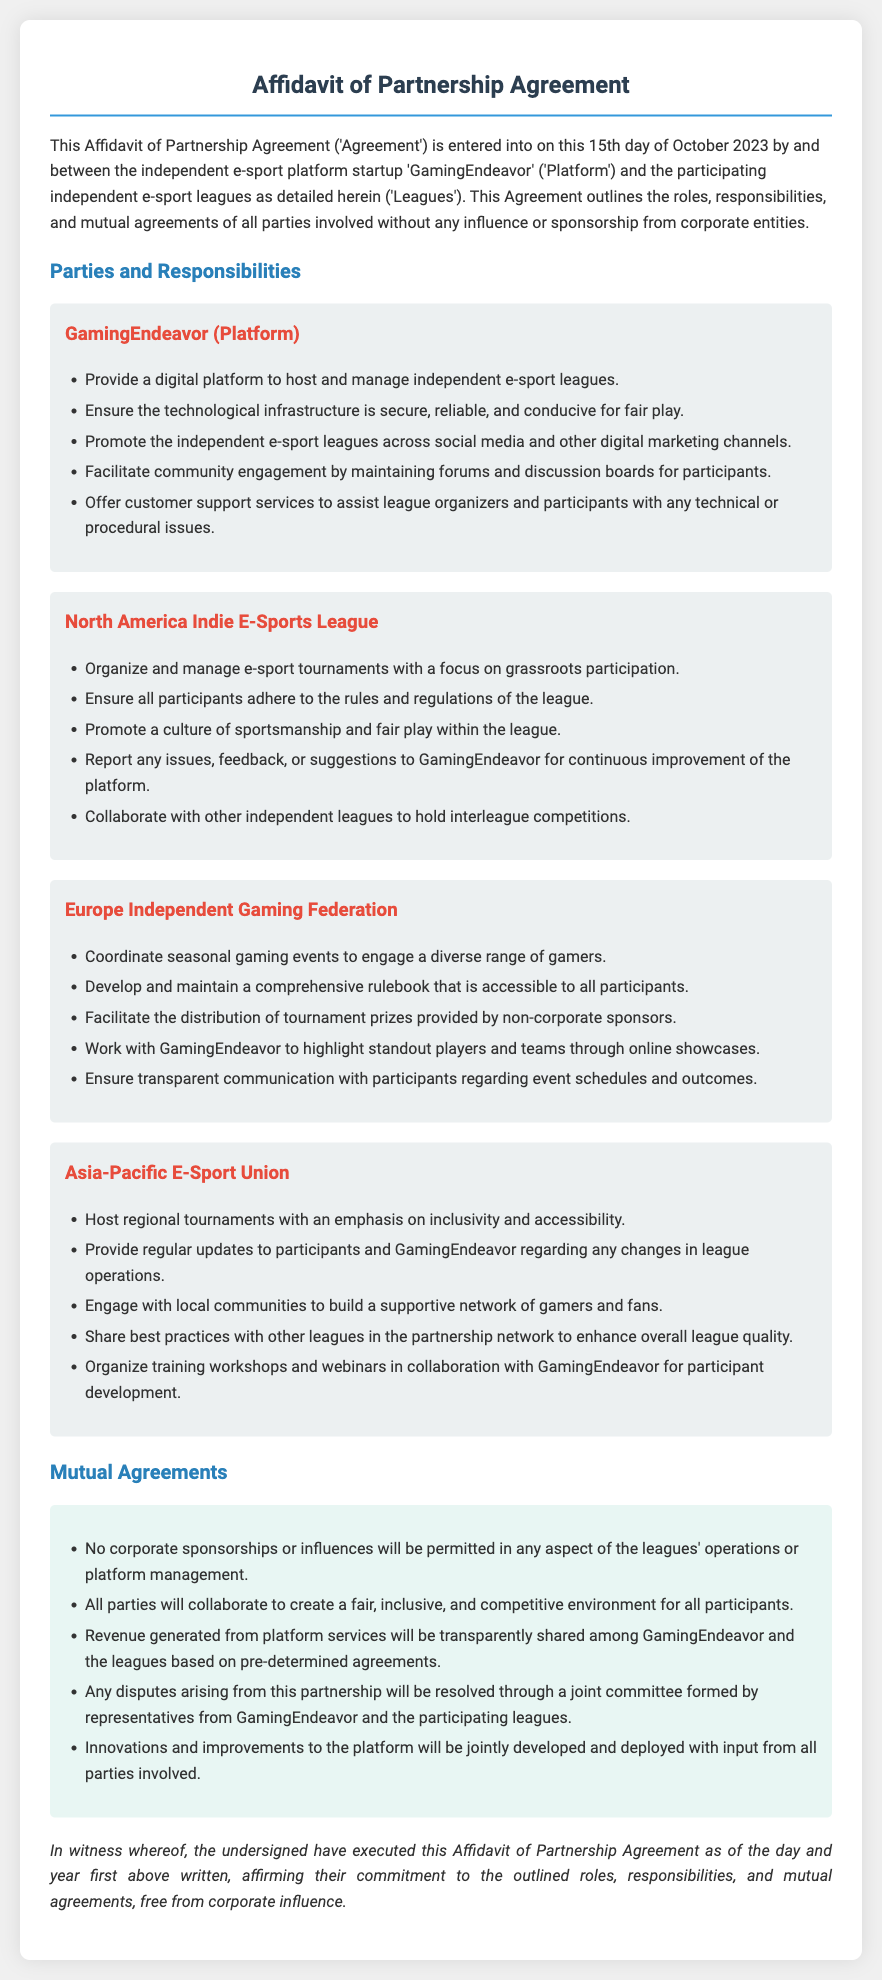What is the date of the Agreement? The document mentions that the Agreement is entered into on the 15th day of October 2023.
Answer: 15th day of October 2023 Who is the Platform in the Agreement? The Platform in the Agreement is referred to as 'GamingEndeavor.'
Answer: GamingEndeavor Which leagues are involved in the partnership? The document lists three leagues, including the North America Indie E-Sports League, Europe Independent Gaming Federation, and Asia-Pacific E-Sport Union.
Answer: North America Indie E-Sports League, Europe Independent Gaming Federation, Asia-Pacific E-Sport Union What is one responsibility of GamingEndeavor? The document states that one of GamingEndeavor's responsibilities is to provide a digital platform to host and manage independent e-sport leagues.
Answer: Provide a digital platform to host and manage independent e-sport leagues What is a mutual agreement regarding corporate influence? The document specifies that no corporate sponsorships or influences will be permitted in any aspect of the leagues' operations or platform management.
Answer: No corporate sponsorships or influences What type of environment are all parties committed to creating? The document outlines that all parties will collaborate to create a fair, inclusive, and competitive environment for all participants.
Answer: Fair, inclusive, and competitive environment Who resolves disputes arising from the partnership? The document states that any disputes arising from this partnership will be resolved through a joint committee formed by representatives from GamingEndeavor and the participating leagues.
Answer: A joint committee What is emphasized by the Asia-Pacific E-Sport Union in their responsibilities? The Asia-Pacific E-Sport Union emphasizes inclusivity and accessibility in hosting regional tournaments.
Answer: Inclusivity and accessibility How will revenue from platform services be shared? The document mentions that revenue generated from platform services will be transparently shared among GamingEndeavor and the leagues based on pre-determined agreements.
Answer: Transparently shared among GamingEndeavor and the leagues 